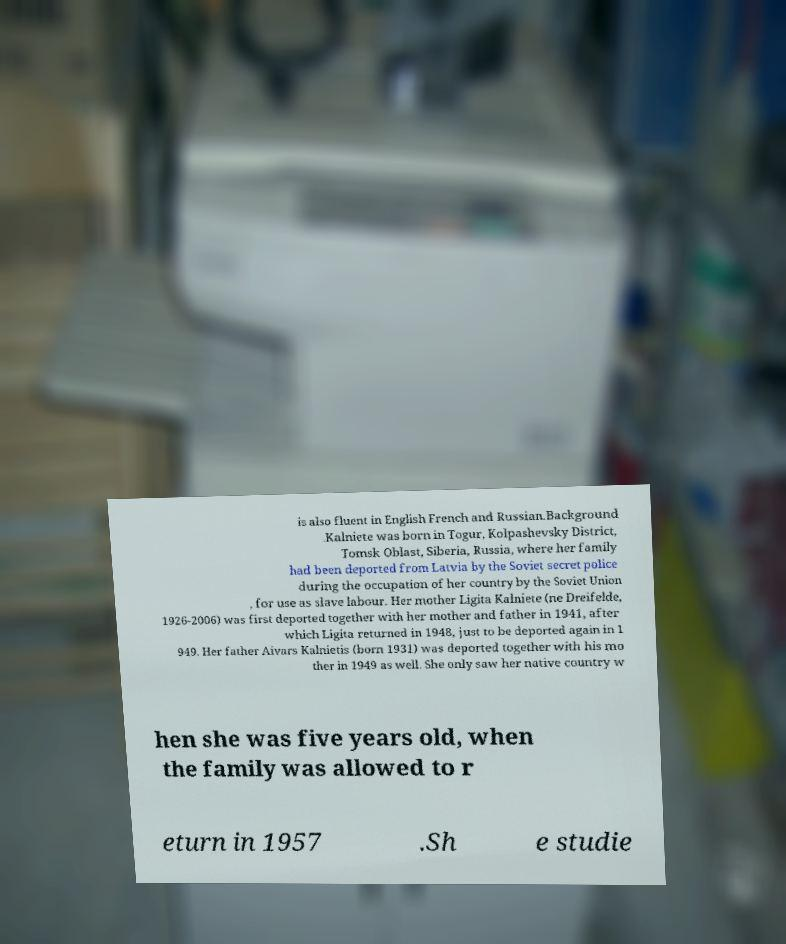Can you accurately transcribe the text from the provided image for me? is also fluent in English French and Russian.Background .Kalniete was born in Togur, Kolpashevsky District, Tomsk Oblast, Siberia, Russia, where her family had been deported from Latvia by the Soviet secret police during the occupation of her country by the Soviet Union , for use as slave labour. Her mother Ligita Kalniete (ne Dreifelde, 1926-2006) was first deported together with her mother and father in 1941, after which Ligita returned in 1948, just to be deported again in 1 949. Her father Aivars Kalnietis (born 1931) was deported together with his mo ther in 1949 as well. She only saw her native country w hen she was five years old, when the family was allowed to r eturn in 1957 .Sh e studie 